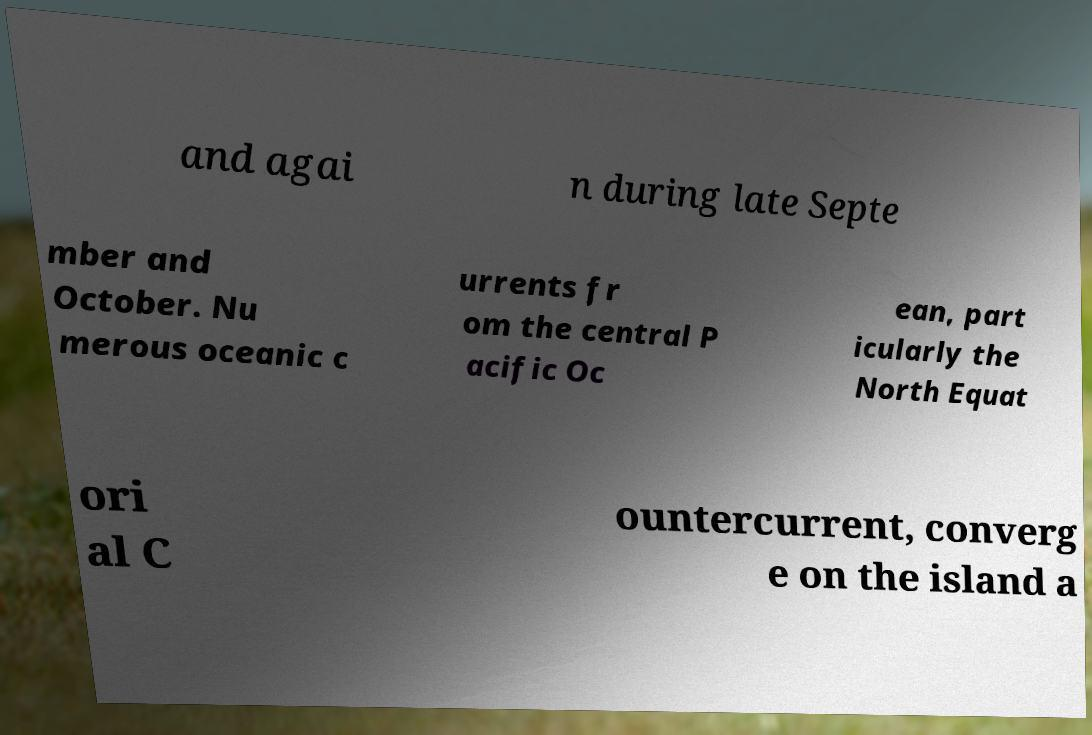Could you extract and type out the text from this image? and agai n during late Septe mber and October. Nu merous oceanic c urrents fr om the central P acific Oc ean, part icularly the North Equat ori al C ountercurrent, converg e on the island a 